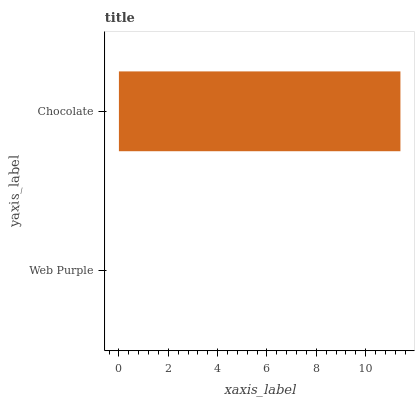Is Web Purple the minimum?
Answer yes or no. Yes. Is Chocolate the maximum?
Answer yes or no. Yes. Is Chocolate the minimum?
Answer yes or no. No. Is Chocolate greater than Web Purple?
Answer yes or no. Yes. Is Web Purple less than Chocolate?
Answer yes or no. Yes. Is Web Purple greater than Chocolate?
Answer yes or no. No. Is Chocolate less than Web Purple?
Answer yes or no. No. Is Chocolate the high median?
Answer yes or no. Yes. Is Web Purple the low median?
Answer yes or no. Yes. Is Web Purple the high median?
Answer yes or no. No. Is Chocolate the low median?
Answer yes or no. No. 